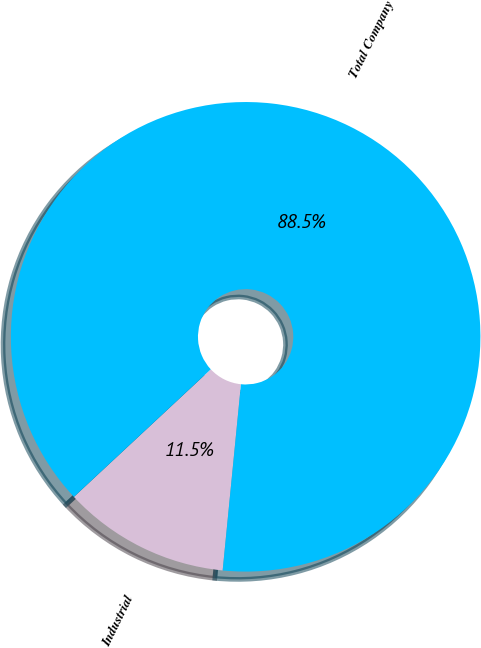Convert chart to OTSL. <chart><loc_0><loc_0><loc_500><loc_500><pie_chart><fcel>Industrial<fcel>Total Company<nl><fcel>11.5%<fcel>88.5%<nl></chart> 